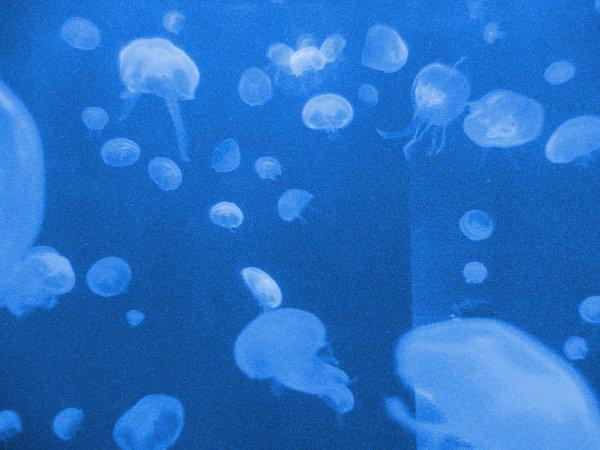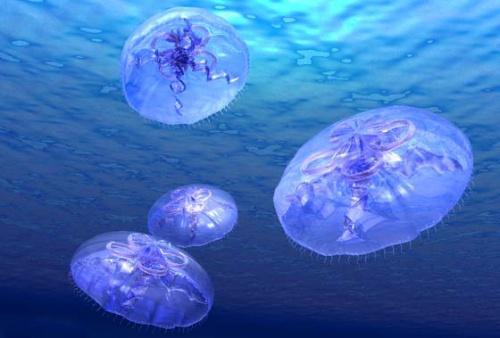The first image is the image on the left, the second image is the image on the right. Analyze the images presented: Is the assertion "One of the images has a person in the lwater with the sting rays." valid? Answer yes or no. No. 